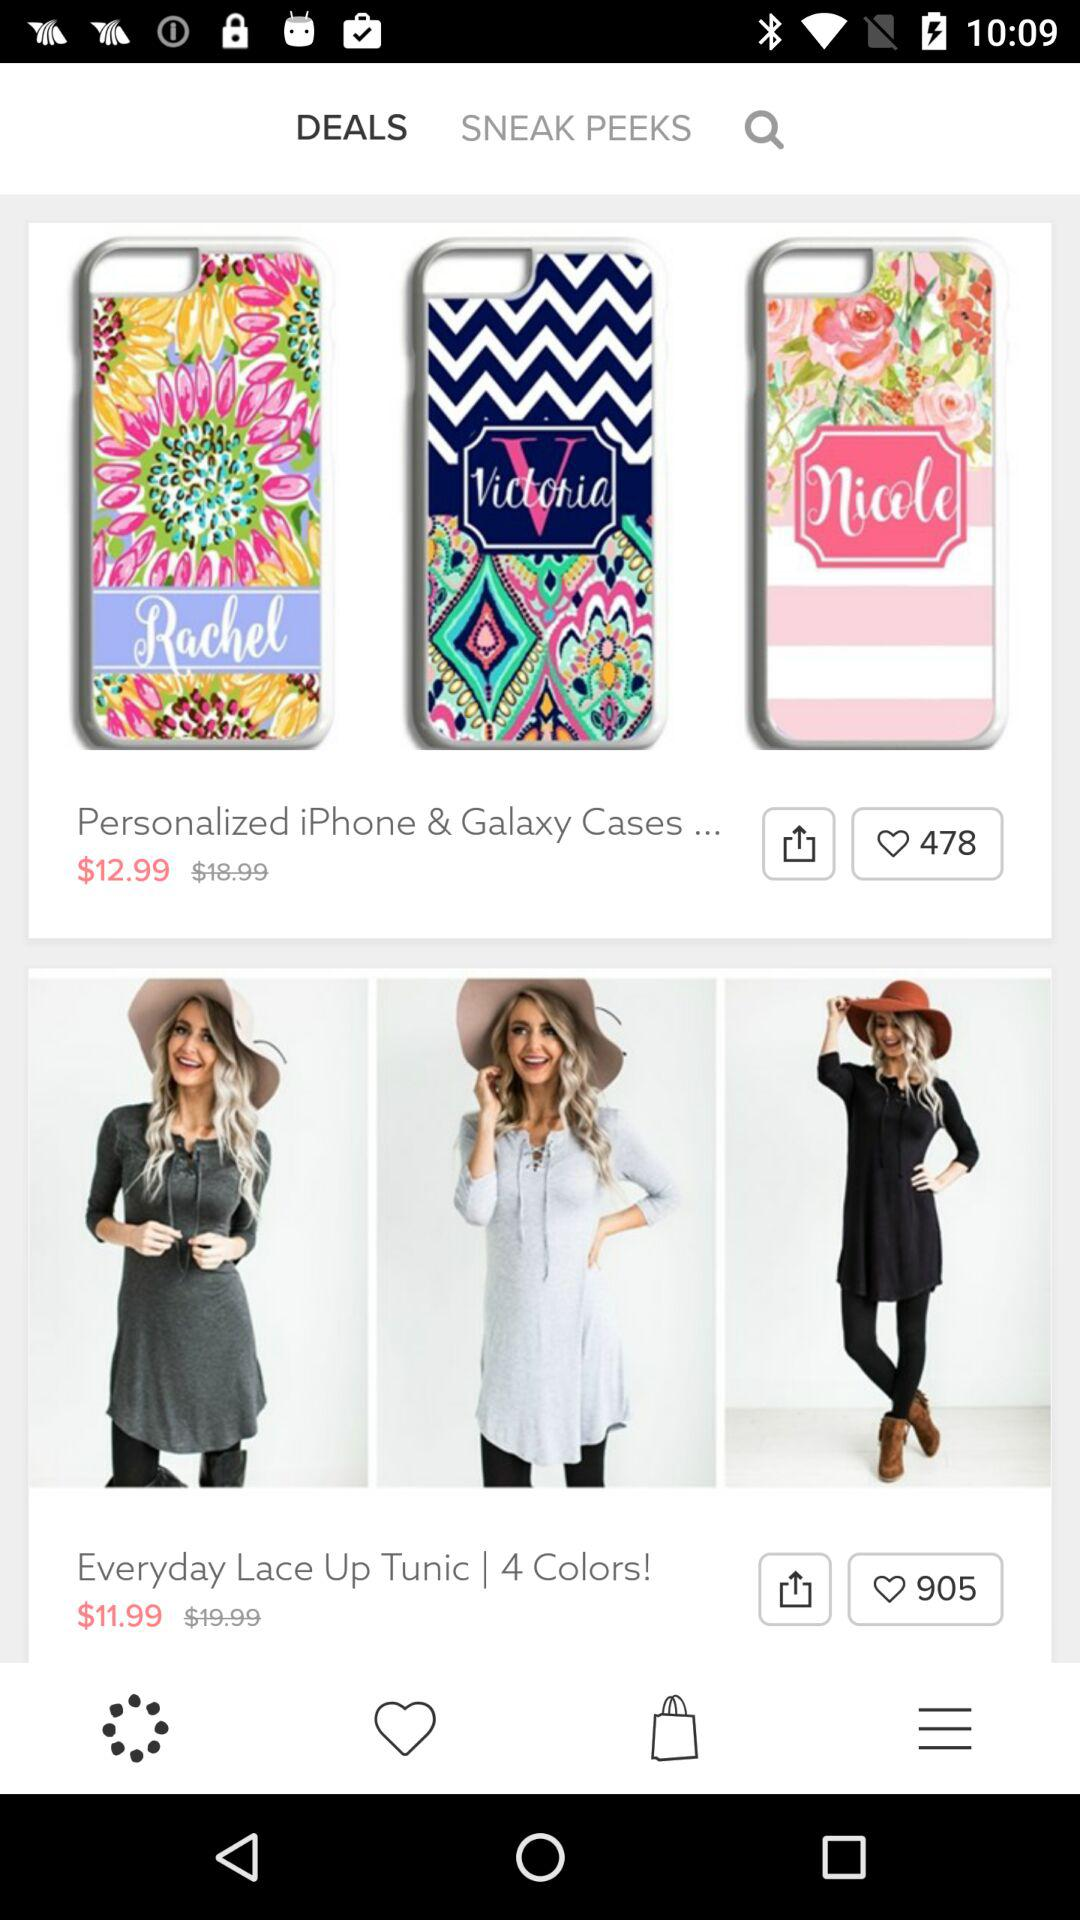What's the price of "Personalized iPhone and Galaxy Cases"? The price of "Personalized iPhone and Galaxy Cases" is $12.99. 